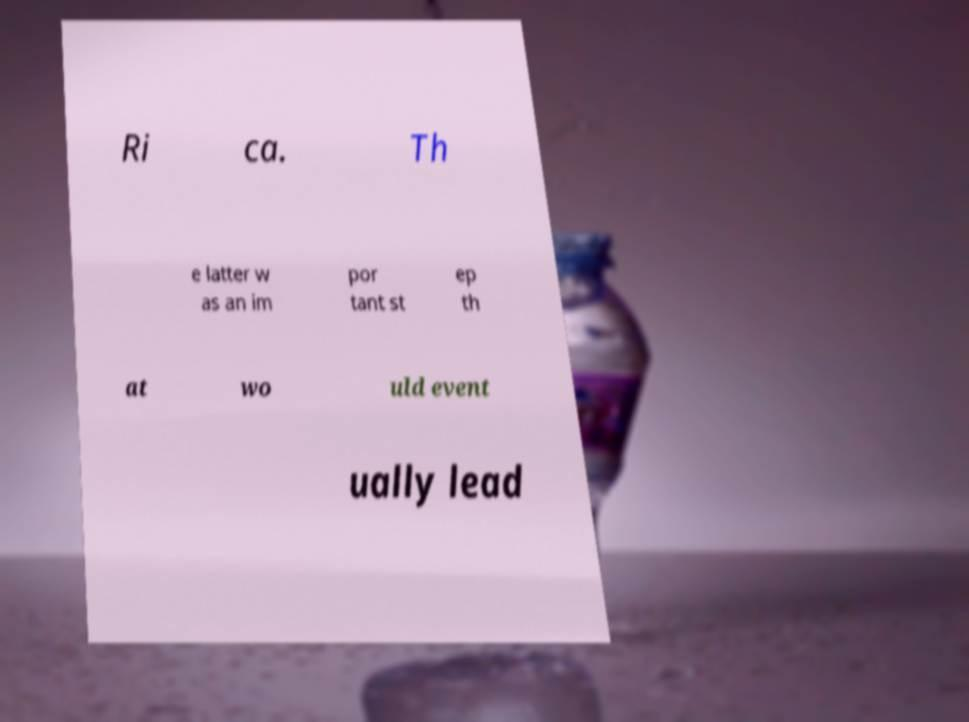There's text embedded in this image that I need extracted. Can you transcribe it verbatim? Ri ca. Th e latter w as an im por tant st ep th at wo uld event ually lead 